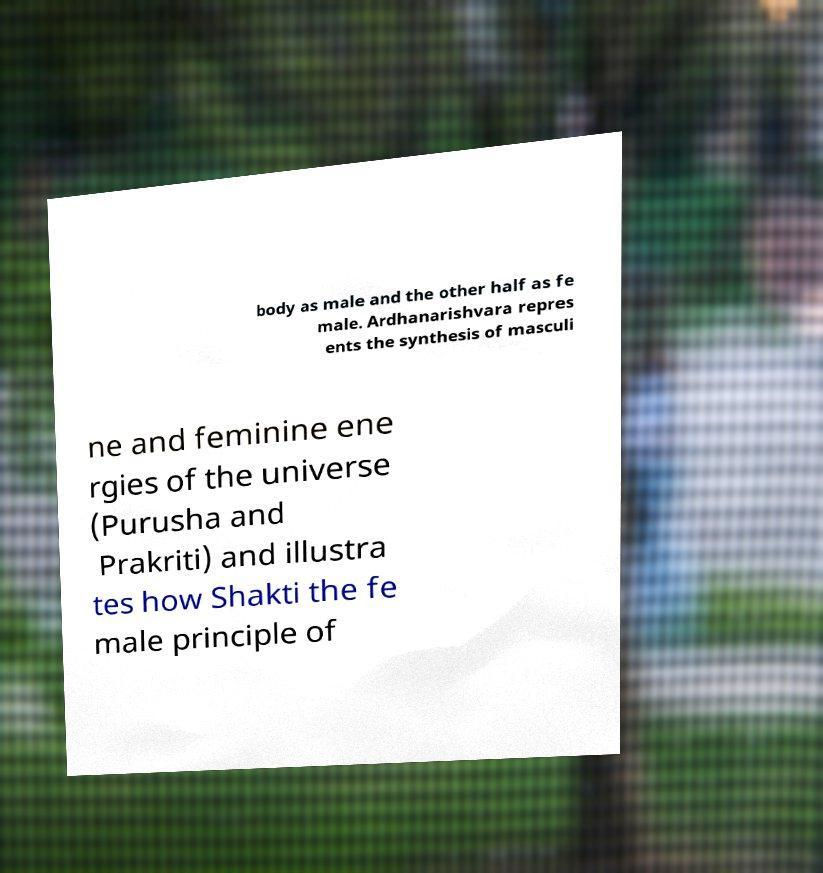Can you accurately transcribe the text from the provided image for me? body as male and the other half as fe male. Ardhanarishvara repres ents the synthesis of masculi ne and feminine ene rgies of the universe (Purusha and Prakriti) and illustra tes how Shakti the fe male principle of 